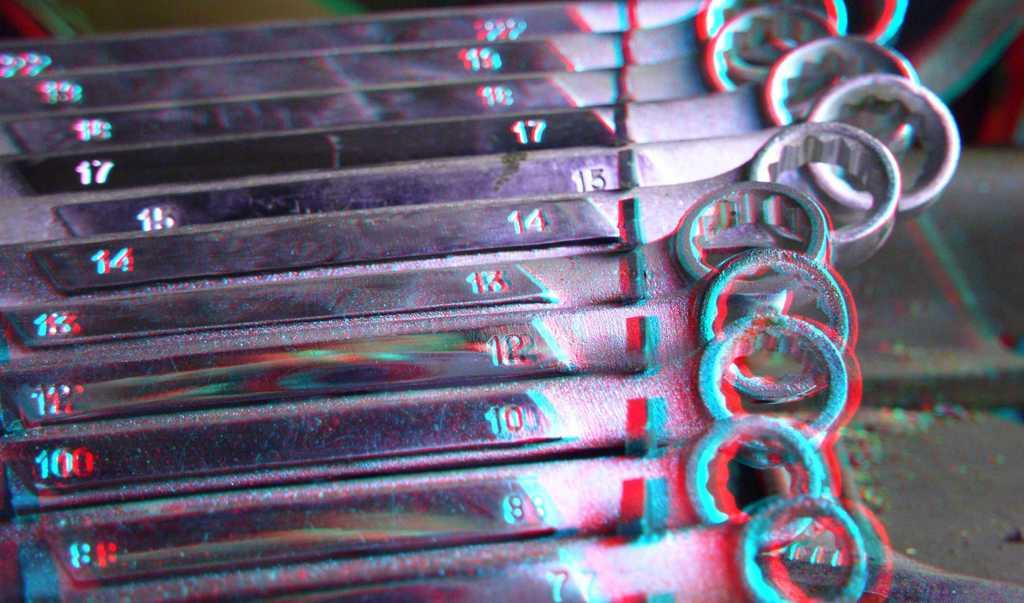What type of tools are shown in the image? There are many spanners in the image. How can the spanners be differentiated from one another? Each spanner has a number on it. What type of clocks are visible in the image? There are no clocks visible in the image; it only features spanners with numbers on them. 